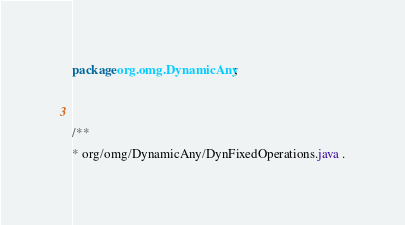<code> <loc_0><loc_0><loc_500><loc_500><_Java_>package org.omg.DynamicAny;


/**
* org/omg/DynamicAny/DynFixedOperations.java .</code> 